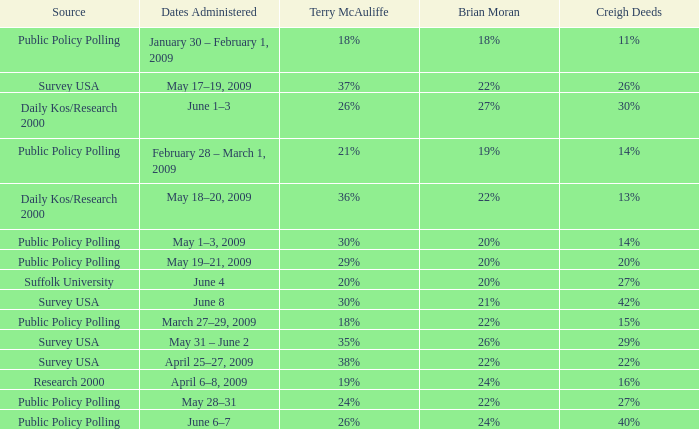Which Terry McAuliffe is it that has a Dates Administered on June 6–7? 26%. 